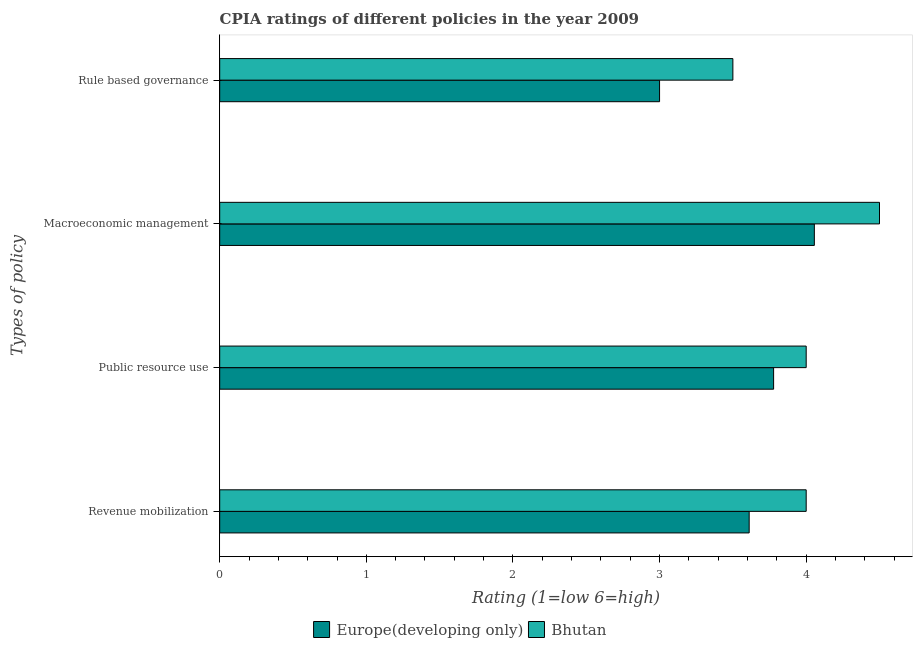How many different coloured bars are there?
Your response must be concise. 2. How many groups of bars are there?
Provide a succinct answer. 4. Are the number of bars on each tick of the Y-axis equal?
Offer a terse response. Yes. How many bars are there on the 1st tick from the top?
Ensure brevity in your answer.  2. How many bars are there on the 1st tick from the bottom?
Provide a short and direct response. 2. What is the label of the 1st group of bars from the top?
Ensure brevity in your answer.  Rule based governance. Across all countries, what is the minimum cpia rating of revenue mobilization?
Make the answer very short. 3.61. In which country was the cpia rating of macroeconomic management maximum?
Your answer should be very brief. Bhutan. In which country was the cpia rating of macroeconomic management minimum?
Ensure brevity in your answer.  Europe(developing only). What is the total cpia rating of public resource use in the graph?
Your answer should be very brief. 7.78. What is the difference between the cpia rating of macroeconomic management in Europe(developing only) and that in Bhutan?
Keep it short and to the point. -0.44. What is the difference between the cpia rating of public resource use in Europe(developing only) and the cpia rating of rule based governance in Bhutan?
Your response must be concise. 0.28. What is the average cpia rating of macroeconomic management per country?
Make the answer very short. 4.28. What is the difference between the cpia rating of revenue mobilization and cpia rating of macroeconomic management in Europe(developing only)?
Your answer should be very brief. -0.44. In how many countries, is the cpia rating of public resource use greater than 3.8 ?
Provide a short and direct response. 1. What is the ratio of the cpia rating of macroeconomic management in Europe(developing only) to that in Bhutan?
Provide a succinct answer. 0.9. Is the cpia rating of public resource use in Bhutan less than that in Europe(developing only)?
Make the answer very short. No. Is the difference between the cpia rating of revenue mobilization in Bhutan and Europe(developing only) greater than the difference between the cpia rating of macroeconomic management in Bhutan and Europe(developing only)?
Your answer should be very brief. No. What is the difference between the highest and the second highest cpia rating of rule based governance?
Offer a very short reply. 0.5. What is the difference between the highest and the lowest cpia rating of rule based governance?
Your response must be concise. 0.5. In how many countries, is the cpia rating of macroeconomic management greater than the average cpia rating of macroeconomic management taken over all countries?
Your answer should be very brief. 1. What does the 2nd bar from the top in Revenue mobilization represents?
Your answer should be compact. Europe(developing only). What does the 1st bar from the bottom in Public resource use represents?
Keep it short and to the point. Europe(developing only). Are all the bars in the graph horizontal?
Make the answer very short. Yes. How many countries are there in the graph?
Give a very brief answer. 2. What is the difference between two consecutive major ticks on the X-axis?
Offer a terse response. 1. Are the values on the major ticks of X-axis written in scientific E-notation?
Give a very brief answer. No. Does the graph contain grids?
Your answer should be compact. No. What is the title of the graph?
Give a very brief answer. CPIA ratings of different policies in the year 2009. What is the label or title of the X-axis?
Offer a very short reply. Rating (1=low 6=high). What is the label or title of the Y-axis?
Your response must be concise. Types of policy. What is the Rating (1=low 6=high) of Europe(developing only) in Revenue mobilization?
Provide a succinct answer. 3.61. What is the Rating (1=low 6=high) of Bhutan in Revenue mobilization?
Provide a short and direct response. 4. What is the Rating (1=low 6=high) in Europe(developing only) in Public resource use?
Provide a succinct answer. 3.78. What is the Rating (1=low 6=high) of Bhutan in Public resource use?
Offer a very short reply. 4. What is the Rating (1=low 6=high) in Europe(developing only) in Macroeconomic management?
Your response must be concise. 4.06. Across all Types of policy, what is the maximum Rating (1=low 6=high) in Europe(developing only)?
Provide a short and direct response. 4.06. Across all Types of policy, what is the minimum Rating (1=low 6=high) in Europe(developing only)?
Offer a terse response. 3. Across all Types of policy, what is the minimum Rating (1=low 6=high) in Bhutan?
Offer a very short reply. 3.5. What is the total Rating (1=low 6=high) of Europe(developing only) in the graph?
Ensure brevity in your answer.  14.44. What is the difference between the Rating (1=low 6=high) in Europe(developing only) in Revenue mobilization and that in Public resource use?
Ensure brevity in your answer.  -0.17. What is the difference between the Rating (1=low 6=high) in Bhutan in Revenue mobilization and that in Public resource use?
Offer a terse response. 0. What is the difference between the Rating (1=low 6=high) in Europe(developing only) in Revenue mobilization and that in Macroeconomic management?
Ensure brevity in your answer.  -0.44. What is the difference between the Rating (1=low 6=high) of Europe(developing only) in Revenue mobilization and that in Rule based governance?
Ensure brevity in your answer.  0.61. What is the difference between the Rating (1=low 6=high) in Europe(developing only) in Public resource use and that in Macroeconomic management?
Offer a very short reply. -0.28. What is the difference between the Rating (1=low 6=high) in Europe(developing only) in Macroeconomic management and that in Rule based governance?
Ensure brevity in your answer.  1.06. What is the difference between the Rating (1=low 6=high) in Europe(developing only) in Revenue mobilization and the Rating (1=low 6=high) in Bhutan in Public resource use?
Offer a terse response. -0.39. What is the difference between the Rating (1=low 6=high) in Europe(developing only) in Revenue mobilization and the Rating (1=low 6=high) in Bhutan in Macroeconomic management?
Offer a terse response. -0.89. What is the difference between the Rating (1=low 6=high) in Europe(developing only) in Public resource use and the Rating (1=low 6=high) in Bhutan in Macroeconomic management?
Your answer should be compact. -0.72. What is the difference between the Rating (1=low 6=high) of Europe(developing only) in Public resource use and the Rating (1=low 6=high) of Bhutan in Rule based governance?
Your answer should be compact. 0.28. What is the difference between the Rating (1=low 6=high) in Europe(developing only) in Macroeconomic management and the Rating (1=low 6=high) in Bhutan in Rule based governance?
Give a very brief answer. 0.56. What is the average Rating (1=low 6=high) in Europe(developing only) per Types of policy?
Your response must be concise. 3.61. What is the average Rating (1=low 6=high) of Bhutan per Types of policy?
Give a very brief answer. 4. What is the difference between the Rating (1=low 6=high) of Europe(developing only) and Rating (1=low 6=high) of Bhutan in Revenue mobilization?
Make the answer very short. -0.39. What is the difference between the Rating (1=low 6=high) of Europe(developing only) and Rating (1=low 6=high) of Bhutan in Public resource use?
Ensure brevity in your answer.  -0.22. What is the difference between the Rating (1=low 6=high) in Europe(developing only) and Rating (1=low 6=high) in Bhutan in Macroeconomic management?
Keep it short and to the point. -0.44. What is the ratio of the Rating (1=low 6=high) of Europe(developing only) in Revenue mobilization to that in Public resource use?
Your answer should be compact. 0.96. What is the ratio of the Rating (1=low 6=high) in Europe(developing only) in Revenue mobilization to that in Macroeconomic management?
Your answer should be compact. 0.89. What is the ratio of the Rating (1=low 6=high) in Bhutan in Revenue mobilization to that in Macroeconomic management?
Your answer should be compact. 0.89. What is the ratio of the Rating (1=low 6=high) in Europe(developing only) in Revenue mobilization to that in Rule based governance?
Offer a terse response. 1.2. What is the ratio of the Rating (1=low 6=high) of Bhutan in Revenue mobilization to that in Rule based governance?
Your answer should be very brief. 1.14. What is the ratio of the Rating (1=low 6=high) in Europe(developing only) in Public resource use to that in Macroeconomic management?
Your answer should be compact. 0.93. What is the ratio of the Rating (1=low 6=high) of Europe(developing only) in Public resource use to that in Rule based governance?
Provide a short and direct response. 1.26. What is the ratio of the Rating (1=low 6=high) of Europe(developing only) in Macroeconomic management to that in Rule based governance?
Ensure brevity in your answer.  1.35. What is the difference between the highest and the second highest Rating (1=low 6=high) in Europe(developing only)?
Keep it short and to the point. 0.28. What is the difference between the highest and the second highest Rating (1=low 6=high) of Bhutan?
Ensure brevity in your answer.  0.5. What is the difference between the highest and the lowest Rating (1=low 6=high) of Europe(developing only)?
Your answer should be compact. 1.06. 